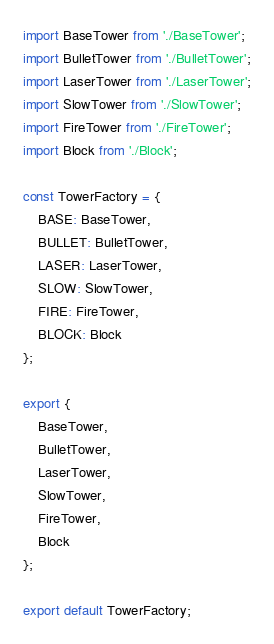Convert code to text. <code><loc_0><loc_0><loc_500><loc_500><_JavaScript_>import BaseTower from './BaseTower';
import BulletTower from './BulletTower';
import LaserTower from './LaserTower';
import SlowTower from './SlowTower';
import FireTower from './FireTower';
import Block from './Block';

const TowerFactory = {
    BASE: BaseTower,
    BULLET: BulletTower,
    LASER: LaserTower,
    SLOW: SlowTower,
    FIRE: FireTower,
    BLOCK: Block
};

export {
    BaseTower,
    BulletTower,
    LaserTower,
    SlowTower,
    FireTower,
    Block
};

export default TowerFactory;</code> 